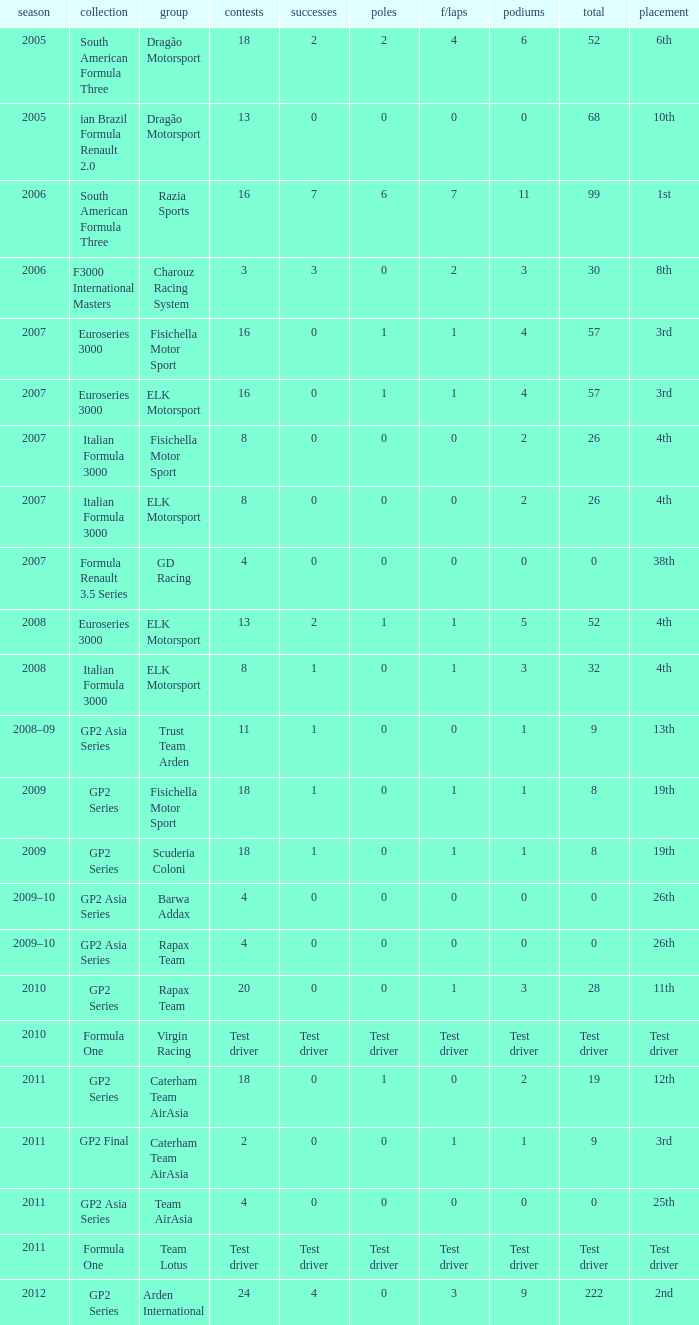What were the points in the year when his Wins were 0, his Podiums were 0, and he drove in 4 races? 0, 0, 0, 0. 